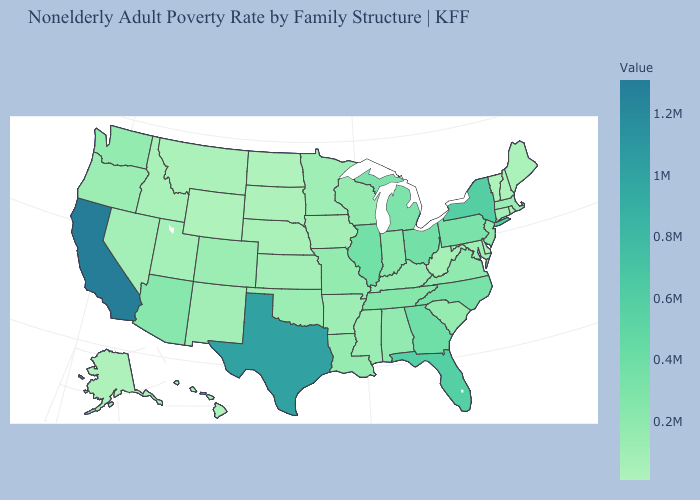Does the map have missing data?
Be succinct. No. Which states hav the highest value in the MidWest?
Answer briefly. Illinois. Does the map have missing data?
Quick response, please. No. Among the states that border Connecticut , does New York have the highest value?
Answer briefly. Yes. Among the states that border Rhode Island , does Massachusetts have the highest value?
Concise answer only. Yes. Does the map have missing data?
Short answer required. No. 